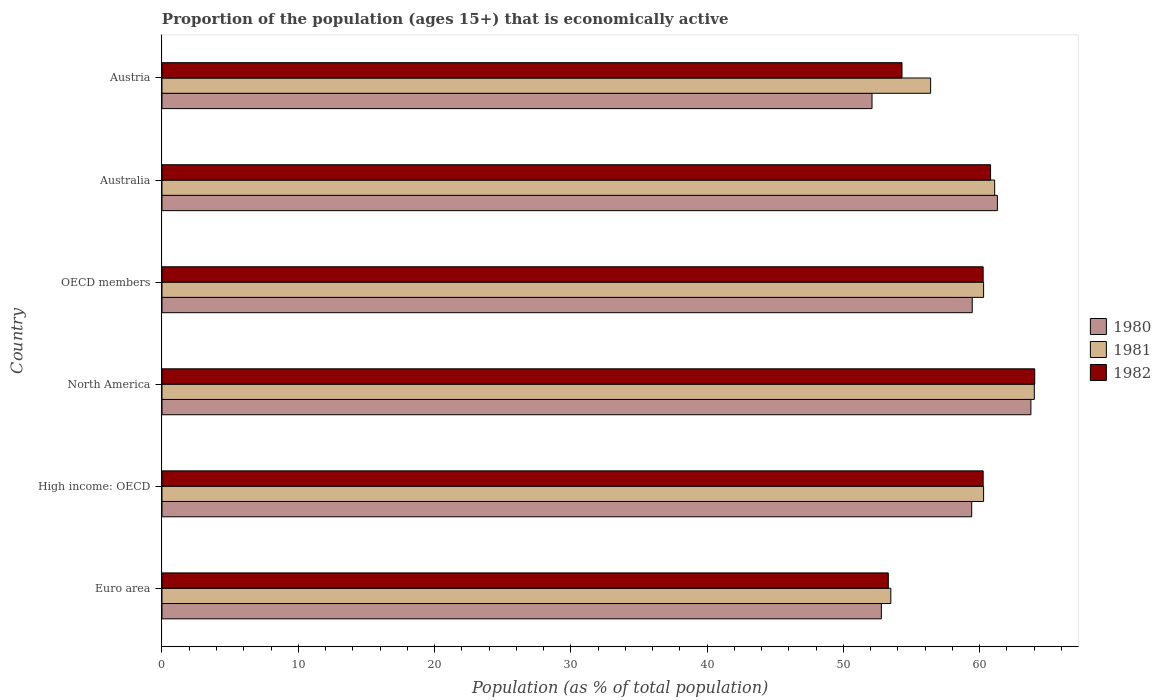How many different coloured bars are there?
Your response must be concise. 3. How many groups of bars are there?
Make the answer very short. 6. Are the number of bars per tick equal to the number of legend labels?
Keep it short and to the point. Yes. Are the number of bars on each tick of the Y-axis equal?
Ensure brevity in your answer.  Yes. How many bars are there on the 2nd tick from the top?
Your response must be concise. 3. How many bars are there on the 2nd tick from the bottom?
Make the answer very short. 3. What is the label of the 2nd group of bars from the top?
Your answer should be compact. Australia. What is the proportion of the population that is economically active in 1980 in OECD members?
Your answer should be very brief. 59.45. Across all countries, what is the maximum proportion of the population that is economically active in 1981?
Offer a very short reply. 64.01. Across all countries, what is the minimum proportion of the population that is economically active in 1981?
Your answer should be very brief. 53.48. What is the total proportion of the population that is economically active in 1980 in the graph?
Provide a short and direct response. 348.81. What is the difference between the proportion of the population that is economically active in 1981 in Euro area and that in High income: OECD?
Offer a very short reply. -6.81. What is the difference between the proportion of the population that is economically active in 1982 in High income: OECD and the proportion of the population that is economically active in 1980 in Australia?
Provide a succinct answer. -1.05. What is the average proportion of the population that is economically active in 1982 per country?
Ensure brevity in your answer.  58.82. What is the difference between the proportion of the population that is economically active in 1982 and proportion of the population that is economically active in 1981 in OECD members?
Provide a succinct answer. -0.03. In how many countries, is the proportion of the population that is economically active in 1981 greater than 20 %?
Ensure brevity in your answer.  6. What is the ratio of the proportion of the population that is economically active in 1980 in Euro area to that in OECD members?
Offer a terse response. 0.89. Is the difference between the proportion of the population that is economically active in 1982 in High income: OECD and North America greater than the difference between the proportion of the population that is economically active in 1981 in High income: OECD and North America?
Keep it short and to the point. No. What is the difference between the highest and the second highest proportion of the population that is economically active in 1980?
Provide a short and direct response. 2.46. What is the difference between the highest and the lowest proportion of the population that is economically active in 1981?
Keep it short and to the point. 10.53. In how many countries, is the proportion of the population that is economically active in 1981 greater than the average proportion of the population that is economically active in 1981 taken over all countries?
Make the answer very short. 4. Is the sum of the proportion of the population that is economically active in 1980 in Australia and Euro area greater than the maximum proportion of the population that is economically active in 1981 across all countries?
Your response must be concise. Yes. What does the 2nd bar from the top in Euro area represents?
Your answer should be very brief. 1981. What does the 3rd bar from the bottom in High income: OECD represents?
Keep it short and to the point. 1982. Are the values on the major ticks of X-axis written in scientific E-notation?
Offer a very short reply. No. Does the graph contain grids?
Keep it short and to the point. No. How many legend labels are there?
Your response must be concise. 3. How are the legend labels stacked?
Offer a terse response. Vertical. What is the title of the graph?
Offer a very short reply. Proportion of the population (ages 15+) that is economically active. What is the label or title of the X-axis?
Your answer should be compact. Population (as % of total population). What is the Population (as % of total population) in 1980 in Euro area?
Make the answer very short. 52.79. What is the Population (as % of total population) in 1981 in Euro area?
Provide a short and direct response. 53.48. What is the Population (as % of total population) of 1982 in Euro area?
Offer a very short reply. 53.3. What is the Population (as % of total population) of 1980 in High income: OECD?
Provide a short and direct response. 59.41. What is the Population (as % of total population) in 1981 in High income: OECD?
Provide a succinct answer. 60.29. What is the Population (as % of total population) of 1982 in High income: OECD?
Give a very brief answer. 60.25. What is the Population (as % of total population) in 1980 in North America?
Keep it short and to the point. 63.76. What is the Population (as % of total population) of 1981 in North America?
Give a very brief answer. 64.01. What is the Population (as % of total population) of 1982 in North America?
Your answer should be very brief. 64.04. What is the Population (as % of total population) of 1980 in OECD members?
Make the answer very short. 59.45. What is the Population (as % of total population) of 1981 in OECD members?
Offer a terse response. 60.29. What is the Population (as % of total population) in 1982 in OECD members?
Offer a very short reply. 60.25. What is the Population (as % of total population) in 1980 in Australia?
Your answer should be compact. 61.3. What is the Population (as % of total population) in 1981 in Australia?
Your answer should be compact. 61.1. What is the Population (as % of total population) of 1982 in Australia?
Your answer should be compact. 60.8. What is the Population (as % of total population) of 1980 in Austria?
Your response must be concise. 52.1. What is the Population (as % of total population) of 1981 in Austria?
Give a very brief answer. 56.4. What is the Population (as % of total population) of 1982 in Austria?
Give a very brief answer. 54.3. Across all countries, what is the maximum Population (as % of total population) in 1980?
Your answer should be compact. 63.76. Across all countries, what is the maximum Population (as % of total population) of 1981?
Your answer should be very brief. 64.01. Across all countries, what is the maximum Population (as % of total population) in 1982?
Provide a short and direct response. 64.04. Across all countries, what is the minimum Population (as % of total population) of 1980?
Provide a short and direct response. 52.1. Across all countries, what is the minimum Population (as % of total population) of 1981?
Your answer should be compact. 53.48. Across all countries, what is the minimum Population (as % of total population) in 1982?
Provide a succinct answer. 53.3. What is the total Population (as % of total population) of 1980 in the graph?
Your answer should be very brief. 348.81. What is the total Population (as % of total population) of 1981 in the graph?
Offer a terse response. 355.56. What is the total Population (as % of total population) in 1982 in the graph?
Offer a terse response. 352.94. What is the difference between the Population (as % of total population) in 1980 in Euro area and that in High income: OECD?
Provide a short and direct response. -6.63. What is the difference between the Population (as % of total population) in 1981 in Euro area and that in High income: OECD?
Provide a short and direct response. -6.81. What is the difference between the Population (as % of total population) in 1982 in Euro area and that in High income: OECD?
Offer a terse response. -6.96. What is the difference between the Population (as % of total population) in 1980 in Euro area and that in North America?
Provide a short and direct response. -10.97. What is the difference between the Population (as % of total population) of 1981 in Euro area and that in North America?
Make the answer very short. -10.53. What is the difference between the Population (as % of total population) of 1982 in Euro area and that in North America?
Your answer should be compact. -10.74. What is the difference between the Population (as % of total population) of 1980 in Euro area and that in OECD members?
Ensure brevity in your answer.  -6.67. What is the difference between the Population (as % of total population) of 1981 in Euro area and that in OECD members?
Make the answer very short. -6.81. What is the difference between the Population (as % of total population) in 1982 in Euro area and that in OECD members?
Your answer should be very brief. -6.96. What is the difference between the Population (as % of total population) of 1980 in Euro area and that in Australia?
Offer a very short reply. -8.51. What is the difference between the Population (as % of total population) of 1981 in Euro area and that in Australia?
Your answer should be very brief. -7.62. What is the difference between the Population (as % of total population) in 1982 in Euro area and that in Australia?
Your answer should be compact. -7.5. What is the difference between the Population (as % of total population) of 1980 in Euro area and that in Austria?
Ensure brevity in your answer.  0.69. What is the difference between the Population (as % of total population) in 1981 in Euro area and that in Austria?
Provide a short and direct response. -2.92. What is the difference between the Population (as % of total population) of 1982 in Euro area and that in Austria?
Give a very brief answer. -1. What is the difference between the Population (as % of total population) of 1980 in High income: OECD and that in North America?
Offer a very short reply. -4.34. What is the difference between the Population (as % of total population) in 1981 in High income: OECD and that in North America?
Your answer should be compact. -3.72. What is the difference between the Population (as % of total population) of 1982 in High income: OECD and that in North America?
Give a very brief answer. -3.78. What is the difference between the Population (as % of total population) of 1980 in High income: OECD and that in OECD members?
Offer a terse response. -0.04. What is the difference between the Population (as % of total population) in 1981 in High income: OECD and that in OECD members?
Your answer should be very brief. 0. What is the difference between the Population (as % of total population) in 1980 in High income: OECD and that in Australia?
Your answer should be compact. -1.89. What is the difference between the Population (as % of total population) of 1981 in High income: OECD and that in Australia?
Provide a succinct answer. -0.81. What is the difference between the Population (as % of total population) of 1982 in High income: OECD and that in Australia?
Provide a succinct answer. -0.55. What is the difference between the Population (as % of total population) in 1980 in High income: OECD and that in Austria?
Give a very brief answer. 7.32. What is the difference between the Population (as % of total population) in 1981 in High income: OECD and that in Austria?
Offer a terse response. 3.89. What is the difference between the Population (as % of total population) of 1982 in High income: OECD and that in Austria?
Offer a terse response. 5.95. What is the difference between the Population (as % of total population) in 1980 in North America and that in OECD members?
Provide a succinct answer. 4.3. What is the difference between the Population (as % of total population) of 1981 in North America and that in OECD members?
Offer a terse response. 3.72. What is the difference between the Population (as % of total population) in 1982 in North America and that in OECD members?
Ensure brevity in your answer.  3.78. What is the difference between the Population (as % of total population) in 1980 in North America and that in Australia?
Give a very brief answer. 2.46. What is the difference between the Population (as % of total population) in 1981 in North America and that in Australia?
Make the answer very short. 2.91. What is the difference between the Population (as % of total population) in 1982 in North America and that in Australia?
Give a very brief answer. 3.24. What is the difference between the Population (as % of total population) of 1980 in North America and that in Austria?
Offer a terse response. 11.66. What is the difference between the Population (as % of total population) in 1981 in North America and that in Austria?
Offer a very short reply. 7.61. What is the difference between the Population (as % of total population) of 1982 in North America and that in Austria?
Your response must be concise. 9.74. What is the difference between the Population (as % of total population) of 1980 in OECD members and that in Australia?
Provide a succinct answer. -1.85. What is the difference between the Population (as % of total population) in 1981 in OECD members and that in Australia?
Make the answer very short. -0.81. What is the difference between the Population (as % of total population) in 1982 in OECD members and that in Australia?
Your answer should be compact. -0.55. What is the difference between the Population (as % of total population) of 1980 in OECD members and that in Austria?
Offer a terse response. 7.35. What is the difference between the Population (as % of total population) in 1981 in OECD members and that in Austria?
Give a very brief answer. 3.89. What is the difference between the Population (as % of total population) of 1982 in OECD members and that in Austria?
Keep it short and to the point. 5.95. What is the difference between the Population (as % of total population) of 1981 in Australia and that in Austria?
Provide a short and direct response. 4.7. What is the difference between the Population (as % of total population) in 1980 in Euro area and the Population (as % of total population) in 1981 in High income: OECD?
Give a very brief answer. -7.5. What is the difference between the Population (as % of total population) in 1980 in Euro area and the Population (as % of total population) in 1982 in High income: OECD?
Your response must be concise. -7.47. What is the difference between the Population (as % of total population) of 1981 in Euro area and the Population (as % of total population) of 1982 in High income: OECD?
Your answer should be compact. -6.78. What is the difference between the Population (as % of total population) of 1980 in Euro area and the Population (as % of total population) of 1981 in North America?
Ensure brevity in your answer.  -11.22. What is the difference between the Population (as % of total population) in 1980 in Euro area and the Population (as % of total population) in 1982 in North America?
Keep it short and to the point. -11.25. What is the difference between the Population (as % of total population) of 1981 in Euro area and the Population (as % of total population) of 1982 in North America?
Keep it short and to the point. -10.56. What is the difference between the Population (as % of total population) in 1980 in Euro area and the Population (as % of total population) in 1981 in OECD members?
Offer a very short reply. -7.5. What is the difference between the Population (as % of total population) of 1980 in Euro area and the Population (as % of total population) of 1982 in OECD members?
Your answer should be very brief. -7.47. What is the difference between the Population (as % of total population) in 1981 in Euro area and the Population (as % of total population) in 1982 in OECD members?
Make the answer very short. -6.78. What is the difference between the Population (as % of total population) in 1980 in Euro area and the Population (as % of total population) in 1981 in Australia?
Your answer should be very brief. -8.31. What is the difference between the Population (as % of total population) in 1980 in Euro area and the Population (as % of total population) in 1982 in Australia?
Give a very brief answer. -8.01. What is the difference between the Population (as % of total population) in 1981 in Euro area and the Population (as % of total population) in 1982 in Australia?
Your answer should be very brief. -7.32. What is the difference between the Population (as % of total population) of 1980 in Euro area and the Population (as % of total population) of 1981 in Austria?
Ensure brevity in your answer.  -3.61. What is the difference between the Population (as % of total population) of 1980 in Euro area and the Population (as % of total population) of 1982 in Austria?
Make the answer very short. -1.51. What is the difference between the Population (as % of total population) in 1981 in Euro area and the Population (as % of total population) in 1982 in Austria?
Your answer should be very brief. -0.82. What is the difference between the Population (as % of total population) of 1980 in High income: OECD and the Population (as % of total population) of 1981 in North America?
Ensure brevity in your answer.  -4.59. What is the difference between the Population (as % of total population) of 1980 in High income: OECD and the Population (as % of total population) of 1982 in North America?
Offer a very short reply. -4.62. What is the difference between the Population (as % of total population) in 1981 in High income: OECD and the Population (as % of total population) in 1982 in North America?
Provide a short and direct response. -3.75. What is the difference between the Population (as % of total population) of 1980 in High income: OECD and the Population (as % of total population) of 1981 in OECD members?
Your response must be concise. -0.87. What is the difference between the Population (as % of total population) of 1980 in High income: OECD and the Population (as % of total population) of 1982 in OECD members?
Keep it short and to the point. -0.84. What is the difference between the Population (as % of total population) of 1981 in High income: OECD and the Population (as % of total population) of 1982 in OECD members?
Your response must be concise. 0.03. What is the difference between the Population (as % of total population) in 1980 in High income: OECD and the Population (as % of total population) in 1981 in Australia?
Your answer should be very brief. -1.69. What is the difference between the Population (as % of total population) of 1980 in High income: OECD and the Population (as % of total population) of 1982 in Australia?
Your answer should be compact. -1.39. What is the difference between the Population (as % of total population) of 1981 in High income: OECD and the Population (as % of total population) of 1982 in Australia?
Provide a succinct answer. -0.51. What is the difference between the Population (as % of total population) in 1980 in High income: OECD and the Population (as % of total population) in 1981 in Austria?
Provide a short and direct response. 3.02. What is the difference between the Population (as % of total population) in 1980 in High income: OECD and the Population (as % of total population) in 1982 in Austria?
Ensure brevity in your answer.  5.12. What is the difference between the Population (as % of total population) in 1981 in High income: OECD and the Population (as % of total population) in 1982 in Austria?
Make the answer very short. 5.99. What is the difference between the Population (as % of total population) of 1980 in North America and the Population (as % of total population) of 1981 in OECD members?
Your answer should be very brief. 3.47. What is the difference between the Population (as % of total population) in 1980 in North America and the Population (as % of total population) in 1982 in OECD members?
Give a very brief answer. 3.5. What is the difference between the Population (as % of total population) of 1981 in North America and the Population (as % of total population) of 1982 in OECD members?
Provide a succinct answer. 3.75. What is the difference between the Population (as % of total population) in 1980 in North America and the Population (as % of total population) in 1981 in Australia?
Provide a succinct answer. 2.66. What is the difference between the Population (as % of total population) in 1980 in North America and the Population (as % of total population) in 1982 in Australia?
Keep it short and to the point. 2.96. What is the difference between the Population (as % of total population) of 1981 in North America and the Population (as % of total population) of 1982 in Australia?
Provide a short and direct response. 3.21. What is the difference between the Population (as % of total population) of 1980 in North America and the Population (as % of total population) of 1981 in Austria?
Give a very brief answer. 7.36. What is the difference between the Population (as % of total population) in 1980 in North America and the Population (as % of total population) in 1982 in Austria?
Keep it short and to the point. 9.46. What is the difference between the Population (as % of total population) of 1981 in North America and the Population (as % of total population) of 1982 in Austria?
Make the answer very short. 9.71. What is the difference between the Population (as % of total population) in 1980 in OECD members and the Population (as % of total population) in 1981 in Australia?
Provide a succinct answer. -1.65. What is the difference between the Population (as % of total population) in 1980 in OECD members and the Population (as % of total population) in 1982 in Australia?
Provide a succinct answer. -1.35. What is the difference between the Population (as % of total population) in 1981 in OECD members and the Population (as % of total population) in 1982 in Australia?
Your response must be concise. -0.51. What is the difference between the Population (as % of total population) of 1980 in OECD members and the Population (as % of total population) of 1981 in Austria?
Offer a terse response. 3.05. What is the difference between the Population (as % of total population) in 1980 in OECD members and the Population (as % of total population) in 1982 in Austria?
Give a very brief answer. 5.15. What is the difference between the Population (as % of total population) in 1981 in OECD members and the Population (as % of total population) in 1982 in Austria?
Ensure brevity in your answer.  5.99. What is the difference between the Population (as % of total population) of 1981 in Australia and the Population (as % of total population) of 1982 in Austria?
Offer a terse response. 6.8. What is the average Population (as % of total population) of 1980 per country?
Your answer should be compact. 58.14. What is the average Population (as % of total population) in 1981 per country?
Offer a very short reply. 59.26. What is the average Population (as % of total population) in 1982 per country?
Offer a very short reply. 58.82. What is the difference between the Population (as % of total population) in 1980 and Population (as % of total population) in 1981 in Euro area?
Make the answer very short. -0.69. What is the difference between the Population (as % of total population) in 1980 and Population (as % of total population) in 1982 in Euro area?
Provide a succinct answer. -0.51. What is the difference between the Population (as % of total population) in 1981 and Population (as % of total population) in 1982 in Euro area?
Provide a succinct answer. 0.18. What is the difference between the Population (as % of total population) in 1980 and Population (as % of total population) in 1981 in High income: OECD?
Your response must be concise. -0.87. What is the difference between the Population (as % of total population) in 1980 and Population (as % of total population) in 1982 in High income: OECD?
Make the answer very short. -0.84. What is the difference between the Population (as % of total population) of 1981 and Population (as % of total population) of 1982 in High income: OECD?
Offer a very short reply. 0.03. What is the difference between the Population (as % of total population) of 1980 and Population (as % of total population) of 1981 in North America?
Provide a succinct answer. -0.25. What is the difference between the Population (as % of total population) in 1980 and Population (as % of total population) in 1982 in North America?
Give a very brief answer. -0.28. What is the difference between the Population (as % of total population) in 1981 and Population (as % of total population) in 1982 in North America?
Provide a succinct answer. -0.03. What is the difference between the Population (as % of total population) in 1980 and Population (as % of total population) in 1981 in OECD members?
Your answer should be compact. -0.83. What is the difference between the Population (as % of total population) in 1980 and Population (as % of total population) in 1982 in OECD members?
Ensure brevity in your answer.  -0.8. What is the difference between the Population (as % of total population) in 1981 and Population (as % of total population) in 1982 in OECD members?
Give a very brief answer. 0.03. What is the difference between the Population (as % of total population) in 1980 and Population (as % of total population) in 1982 in Australia?
Your answer should be very brief. 0.5. What is the difference between the Population (as % of total population) of 1981 and Population (as % of total population) of 1982 in Australia?
Provide a short and direct response. 0.3. What is the difference between the Population (as % of total population) in 1980 and Population (as % of total population) in 1981 in Austria?
Offer a terse response. -4.3. What is the difference between the Population (as % of total population) of 1980 and Population (as % of total population) of 1982 in Austria?
Provide a succinct answer. -2.2. What is the ratio of the Population (as % of total population) in 1980 in Euro area to that in High income: OECD?
Your response must be concise. 0.89. What is the ratio of the Population (as % of total population) in 1981 in Euro area to that in High income: OECD?
Ensure brevity in your answer.  0.89. What is the ratio of the Population (as % of total population) of 1982 in Euro area to that in High income: OECD?
Your response must be concise. 0.88. What is the ratio of the Population (as % of total population) in 1980 in Euro area to that in North America?
Offer a very short reply. 0.83. What is the ratio of the Population (as % of total population) of 1981 in Euro area to that in North America?
Ensure brevity in your answer.  0.84. What is the ratio of the Population (as % of total population) in 1982 in Euro area to that in North America?
Give a very brief answer. 0.83. What is the ratio of the Population (as % of total population) in 1980 in Euro area to that in OECD members?
Give a very brief answer. 0.89. What is the ratio of the Population (as % of total population) in 1981 in Euro area to that in OECD members?
Offer a terse response. 0.89. What is the ratio of the Population (as % of total population) in 1982 in Euro area to that in OECD members?
Your answer should be compact. 0.88. What is the ratio of the Population (as % of total population) of 1980 in Euro area to that in Australia?
Offer a terse response. 0.86. What is the ratio of the Population (as % of total population) in 1981 in Euro area to that in Australia?
Provide a short and direct response. 0.88. What is the ratio of the Population (as % of total population) of 1982 in Euro area to that in Australia?
Provide a short and direct response. 0.88. What is the ratio of the Population (as % of total population) of 1980 in Euro area to that in Austria?
Offer a terse response. 1.01. What is the ratio of the Population (as % of total population) of 1981 in Euro area to that in Austria?
Your answer should be compact. 0.95. What is the ratio of the Population (as % of total population) of 1982 in Euro area to that in Austria?
Keep it short and to the point. 0.98. What is the ratio of the Population (as % of total population) in 1980 in High income: OECD to that in North America?
Offer a terse response. 0.93. What is the ratio of the Population (as % of total population) of 1981 in High income: OECD to that in North America?
Make the answer very short. 0.94. What is the ratio of the Population (as % of total population) in 1982 in High income: OECD to that in North America?
Offer a terse response. 0.94. What is the ratio of the Population (as % of total population) of 1982 in High income: OECD to that in OECD members?
Ensure brevity in your answer.  1. What is the ratio of the Population (as % of total population) of 1980 in High income: OECD to that in Australia?
Your answer should be compact. 0.97. What is the ratio of the Population (as % of total population) in 1981 in High income: OECD to that in Australia?
Your response must be concise. 0.99. What is the ratio of the Population (as % of total population) in 1982 in High income: OECD to that in Australia?
Offer a terse response. 0.99. What is the ratio of the Population (as % of total population) of 1980 in High income: OECD to that in Austria?
Your response must be concise. 1.14. What is the ratio of the Population (as % of total population) in 1981 in High income: OECD to that in Austria?
Your answer should be compact. 1.07. What is the ratio of the Population (as % of total population) of 1982 in High income: OECD to that in Austria?
Your response must be concise. 1.11. What is the ratio of the Population (as % of total population) of 1980 in North America to that in OECD members?
Provide a succinct answer. 1.07. What is the ratio of the Population (as % of total population) in 1981 in North America to that in OECD members?
Keep it short and to the point. 1.06. What is the ratio of the Population (as % of total population) in 1982 in North America to that in OECD members?
Give a very brief answer. 1.06. What is the ratio of the Population (as % of total population) of 1980 in North America to that in Australia?
Keep it short and to the point. 1.04. What is the ratio of the Population (as % of total population) of 1981 in North America to that in Australia?
Your answer should be compact. 1.05. What is the ratio of the Population (as % of total population) in 1982 in North America to that in Australia?
Provide a short and direct response. 1.05. What is the ratio of the Population (as % of total population) of 1980 in North America to that in Austria?
Offer a terse response. 1.22. What is the ratio of the Population (as % of total population) in 1981 in North America to that in Austria?
Give a very brief answer. 1.13. What is the ratio of the Population (as % of total population) of 1982 in North America to that in Austria?
Provide a short and direct response. 1.18. What is the ratio of the Population (as % of total population) of 1980 in OECD members to that in Australia?
Offer a terse response. 0.97. What is the ratio of the Population (as % of total population) in 1981 in OECD members to that in Australia?
Ensure brevity in your answer.  0.99. What is the ratio of the Population (as % of total population) of 1982 in OECD members to that in Australia?
Provide a short and direct response. 0.99. What is the ratio of the Population (as % of total population) of 1980 in OECD members to that in Austria?
Offer a terse response. 1.14. What is the ratio of the Population (as % of total population) of 1981 in OECD members to that in Austria?
Provide a short and direct response. 1.07. What is the ratio of the Population (as % of total population) in 1982 in OECD members to that in Austria?
Your response must be concise. 1.11. What is the ratio of the Population (as % of total population) of 1980 in Australia to that in Austria?
Keep it short and to the point. 1.18. What is the ratio of the Population (as % of total population) of 1981 in Australia to that in Austria?
Ensure brevity in your answer.  1.08. What is the ratio of the Population (as % of total population) of 1982 in Australia to that in Austria?
Keep it short and to the point. 1.12. What is the difference between the highest and the second highest Population (as % of total population) in 1980?
Your answer should be compact. 2.46. What is the difference between the highest and the second highest Population (as % of total population) in 1981?
Provide a short and direct response. 2.91. What is the difference between the highest and the second highest Population (as % of total population) of 1982?
Ensure brevity in your answer.  3.24. What is the difference between the highest and the lowest Population (as % of total population) in 1980?
Your response must be concise. 11.66. What is the difference between the highest and the lowest Population (as % of total population) in 1981?
Your answer should be compact. 10.53. What is the difference between the highest and the lowest Population (as % of total population) in 1982?
Provide a short and direct response. 10.74. 